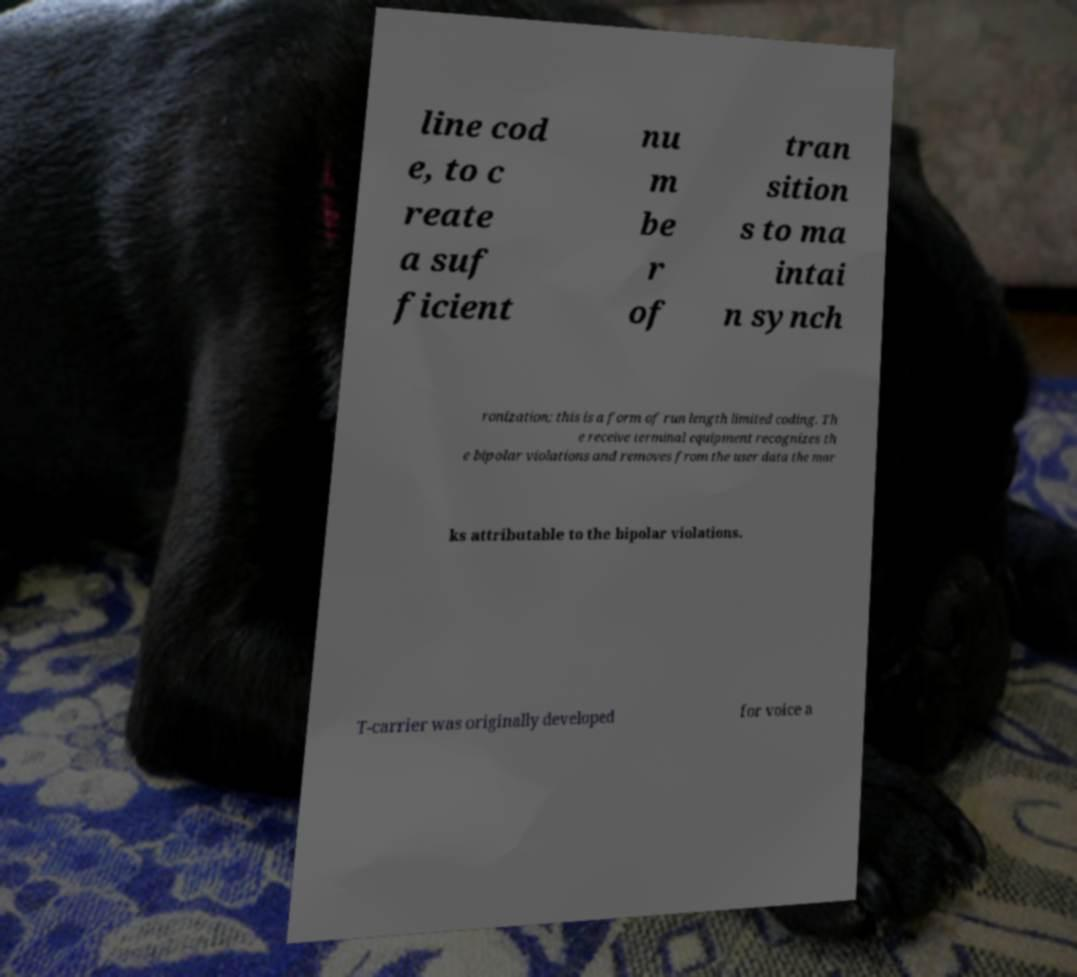Could you assist in decoding the text presented in this image and type it out clearly? line cod e, to c reate a suf ficient nu m be r of tran sition s to ma intai n synch ronization; this is a form of run length limited coding. Th e receive terminal equipment recognizes th e bipolar violations and removes from the user data the mar ks attributable to the bipolar violations. T-carrier was originally developed for voice a 